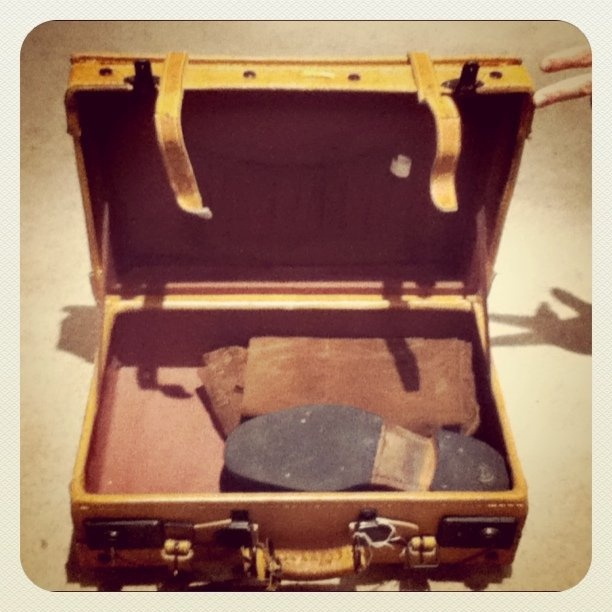Describe the objects in this image and their specific colors. I can see suitcase in ivory, maroon, brown, black, and tan tones and people in ivory, tan, and salmon tones in this image. 